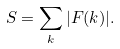<formula> <loc_0><loc_0><loc_500><loc_500>S = \sum _ { k } | F ( { k } ) | .</formula> 